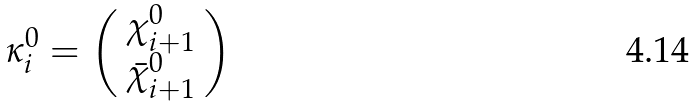Convert formula to latex. <formula><loc_0><loc_0><loc_500><loc_500>\kappa _ { i } ^ { 0 } = \left ( \begin{array} { c } \chi _ { i + 1 } ^ { 0 } \\ \bar { \chi } _ { i + 1 } ^ { 0 } \end{array} \right )</formula> 